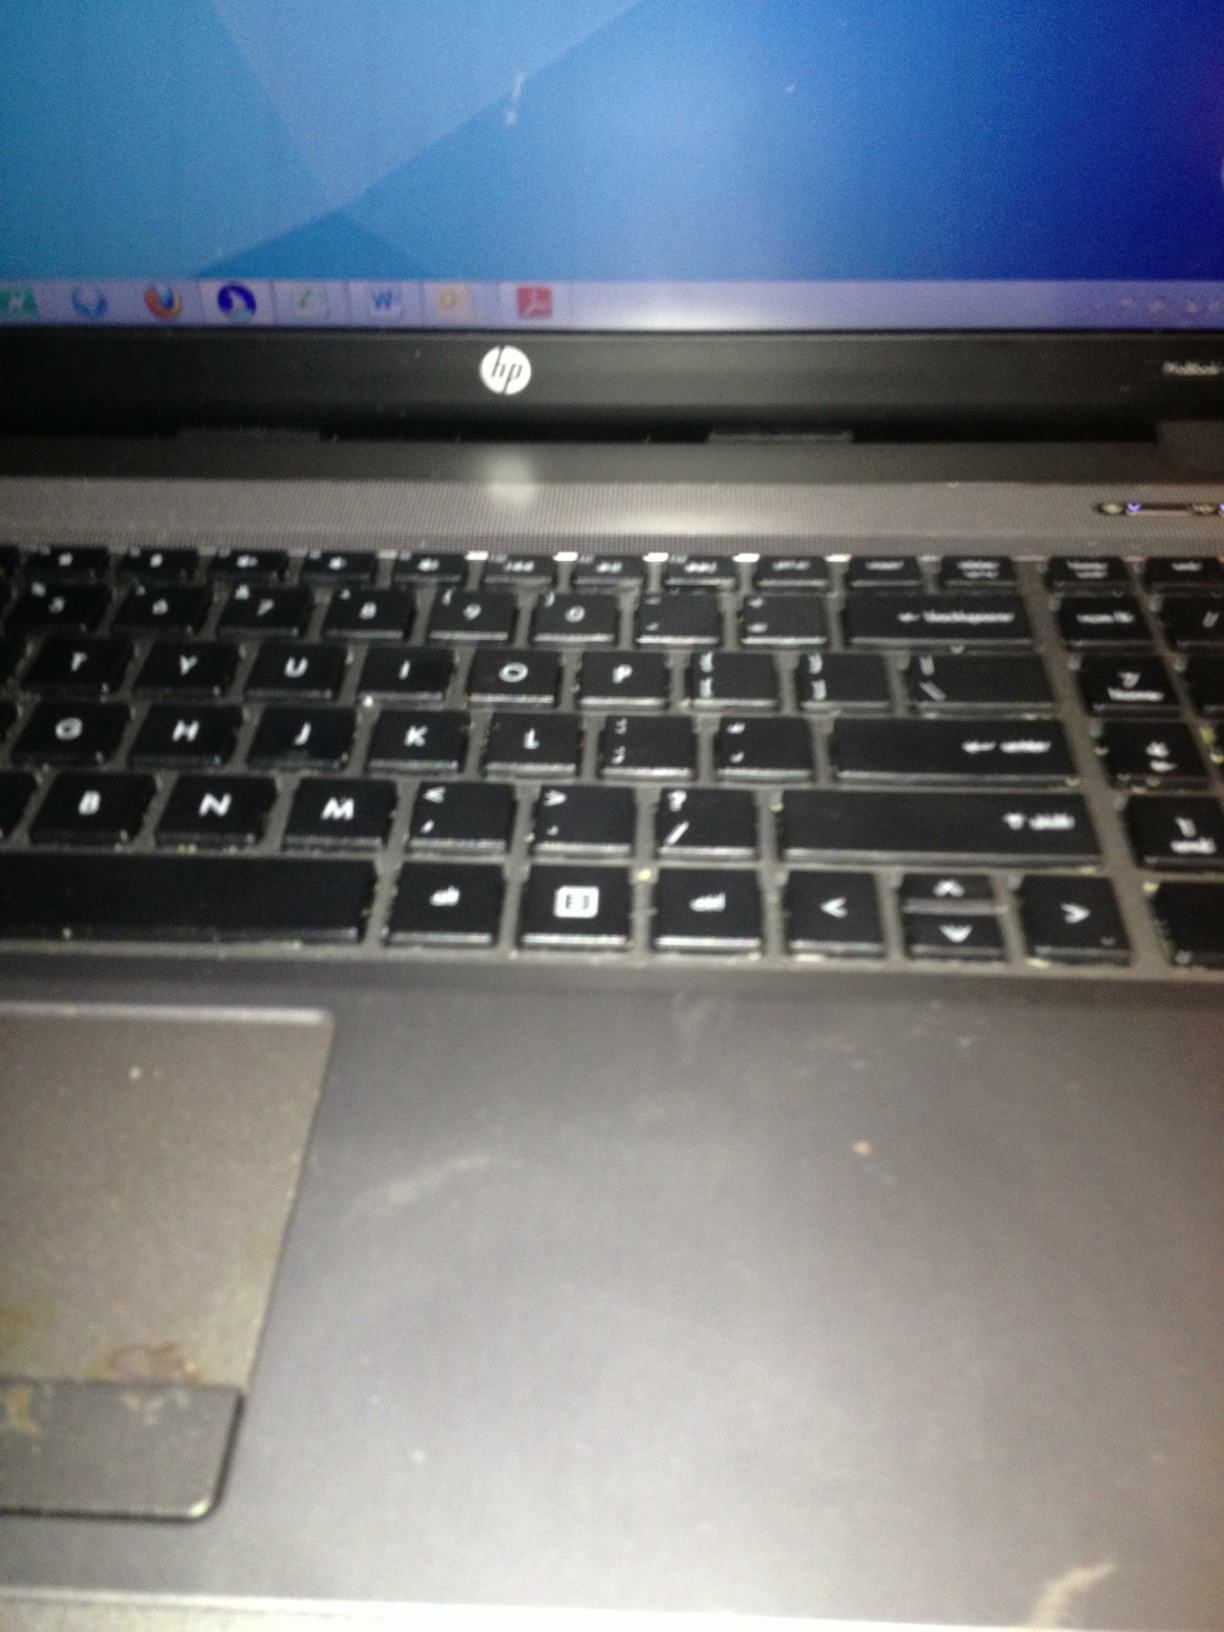What are some realistic scenarios where this laptop would still be highly useful? This HP laptop would be highly useful in several realistic scenarios despite its wear and tear:
1. **Office Work:** Perfect for handling tasks such as word processing, spreadsheets, and web browsing.
2. **Educational Use:** Great for online classes, research, and writing assignments.
3. **Entertainment:** Can be used for streaming videos, light photo editing, and social media.
4. **Remote Work:** Suitable for video calls, emails, and remote desktop applications.
While it might not be suited for high-end gaming or heavy graphic design, it remains functional for a wide range of everyday tasks. 